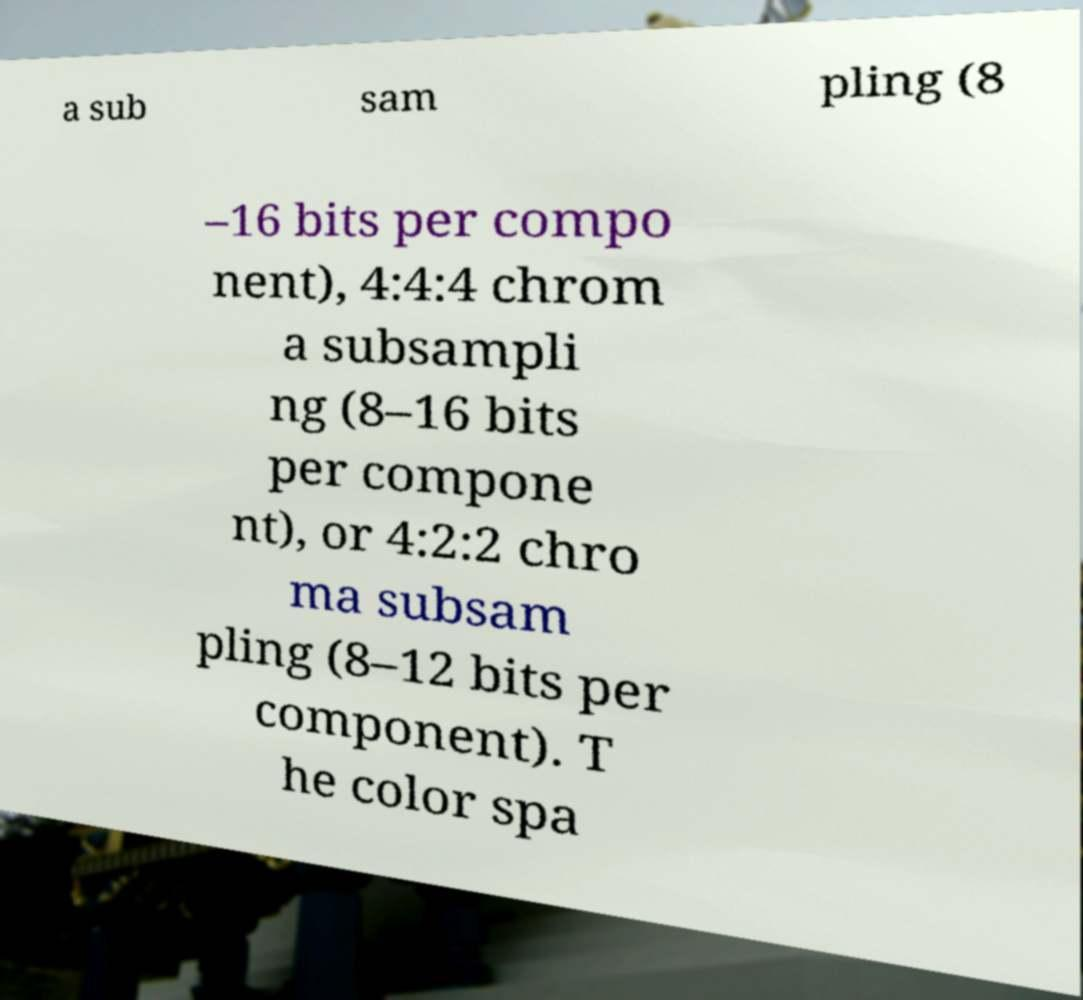Please identify and transcribe the text found in this image. a sub sam pling (8 –16 bits per compo nent), 4:4:4 chrom a subsampli ng (8–16 bits per compone nt), or 4:2:2 chro ma subsam pling (8–12 bits per component). T he color spa 